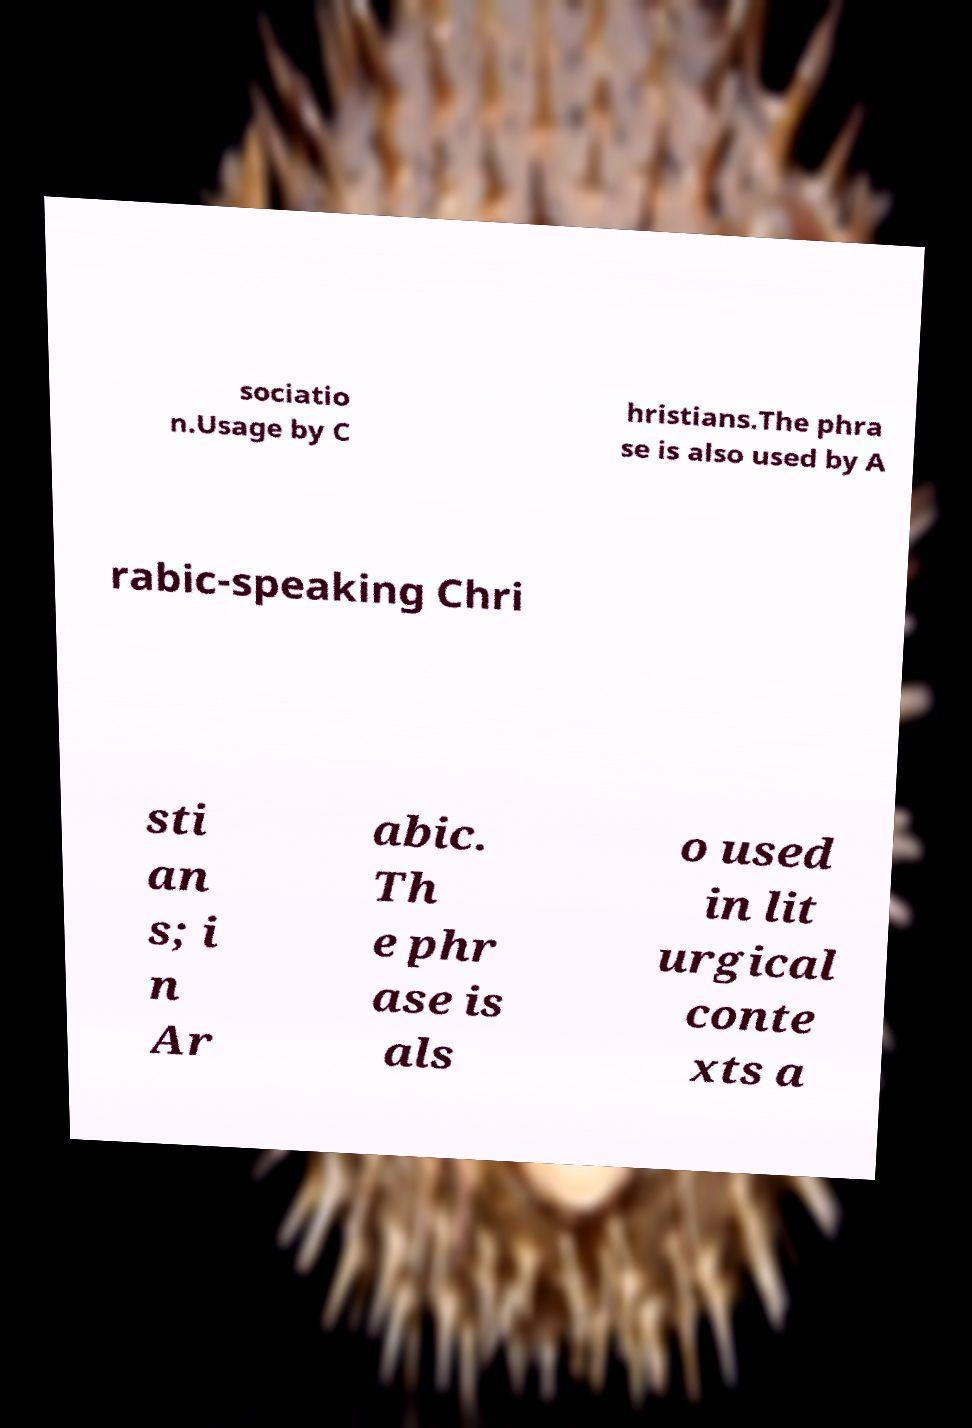There's text embedded in this image that I need extracted. Can you transcribe it verbatim? sociatio n.Usage by C hristians.The phra se is also used by A rabic-speaking Chri sti an s; i n Ar abic. Th e phr ase is als o used in lit urgical conte xts a 